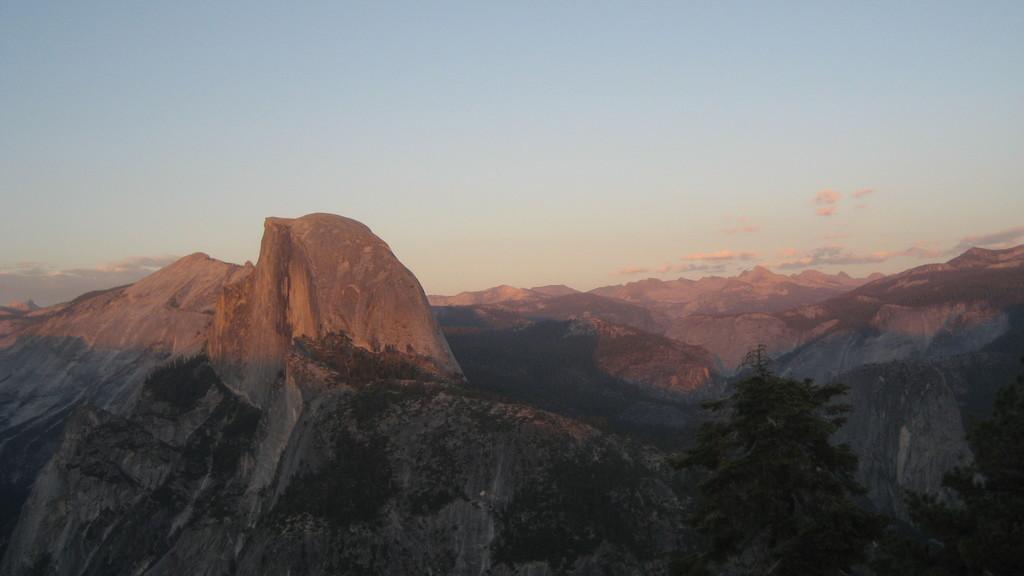Please provide a concise description of this image. In this image we can see the mountains, some trees on the ground and at the top there is the cloudy sky. 